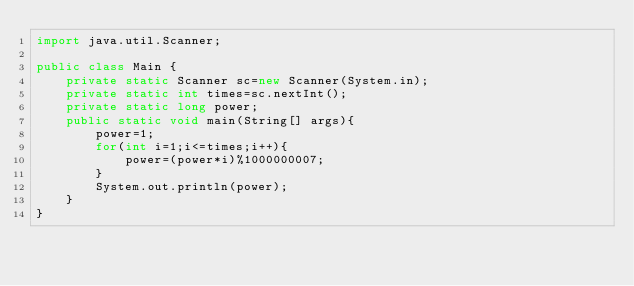<code> <loc_0><loc_0><loc_500><loc_500><_Java_>import java.util.Scanner;

public class Main {
	private static Scanner sc=new Scanner(System.in);
	private static int times=sc.nextInt();
	private static long power;
	public static void main(String[] args){
		power=1;
		for(int i=1;i<=times;i++){
			power=(power*i)%1000000007;
		}
		System.out.println(power);
	}
}</code> 